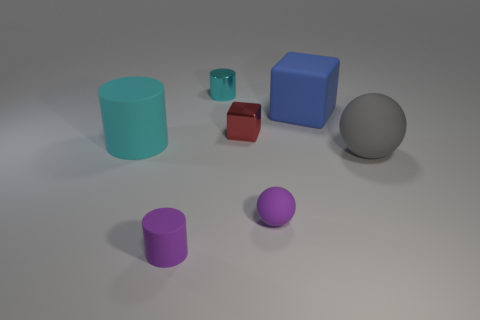Subtract all green cubes. How many cyan cylinders are left? 2 Subtract 1 cylinders. How many cylinders are left? 2 Subtract all tiny cylinders. How many cylinders are left? 1 Add 2 tiny metallic things. How many objects exist? 9 Subtract all spheres. How many objects are left? 5 Add 6 small cyan shiny cylinders. How many small cyan shiny cylinders are left? 7 Add 1 cyan shiny things. How many cyan shiny things exist? 2 Subtract 0 green spheres. How many objects are left? 7 Subtract all large gray metallic objects. Subtract all cyan metal cylinders. How many objects are left? 6 